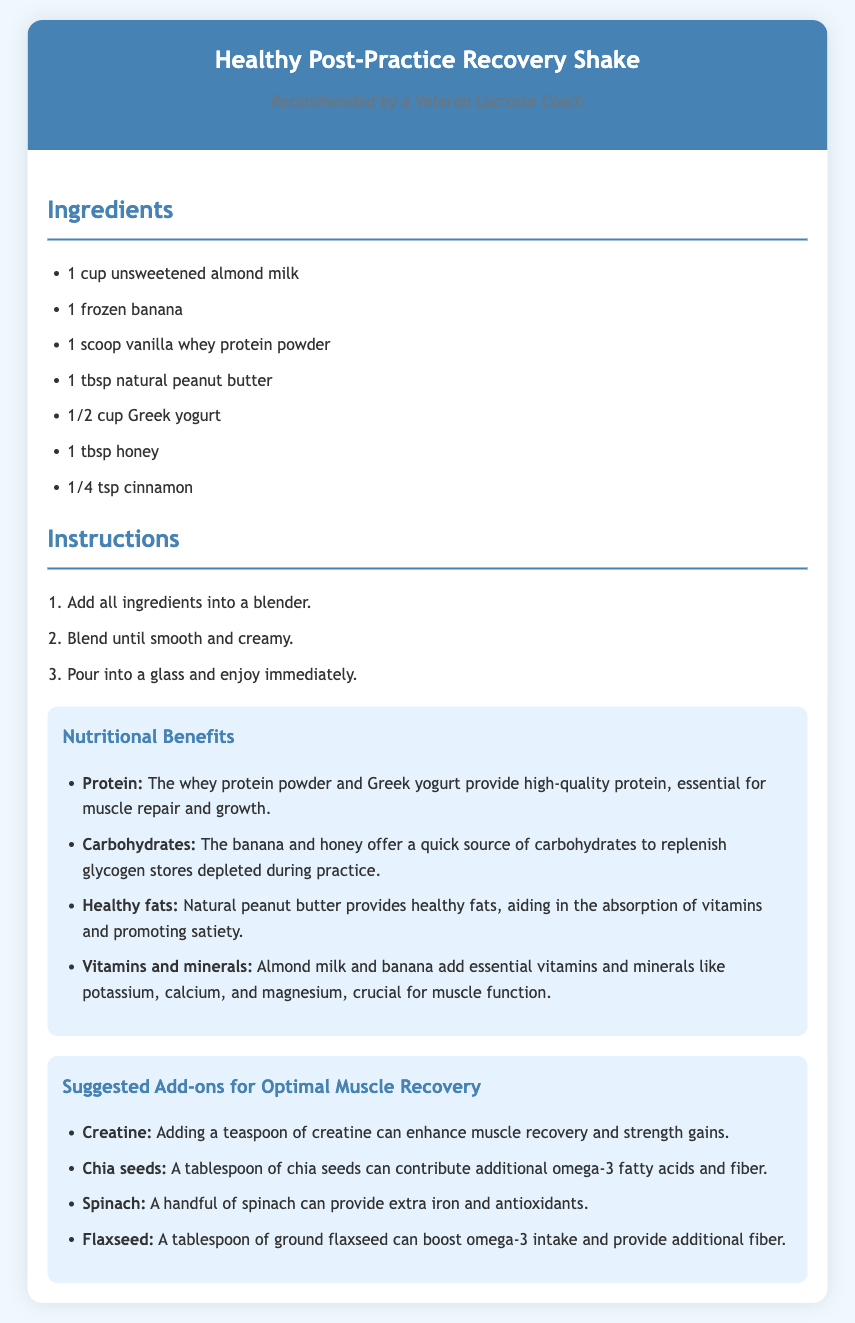What is the base of the recovery shake? The base of the recovery shake is unsweetened almond milk.
Answer: unsweetened almond milk How many ingredients are listed for the shake? The recipe lists a total of 7 ingredients.
Answer: 7 What is the main protein source in the shake? The main protein source in the shake is vanilla whey protein powder.
Answer: vanilla whey protein powder What nutrient do bananas primarily provide in the shake? Bananas primarily provide carbohydrates to replenish glycogen stores.
Answer: carbohydrates What is the purpose of adding natural peanut butter? Adding natural peanut butter provides healthy fats, aiding in vitamin absorption.
Answer: healthy fats How many steps are in the preparation instructions? There are 3 steps in the preparation instructions.
Answer: 3 steps What is a suggested add-on for omega-3 fatty acids? A tablespoon of chia seeds is suggested for omega-3 fatty acids.
Answer: chia seeds Which ingredient adds potassium and magnesium? Almond milk and banana add essential vitamins and minerals like potassium and magnesium.
Answer: almond milk and banana What is the total teaspoon measure suggested for creatine? The suggested amount for creatine is a teaspoon.
Answer: a teaspoon 